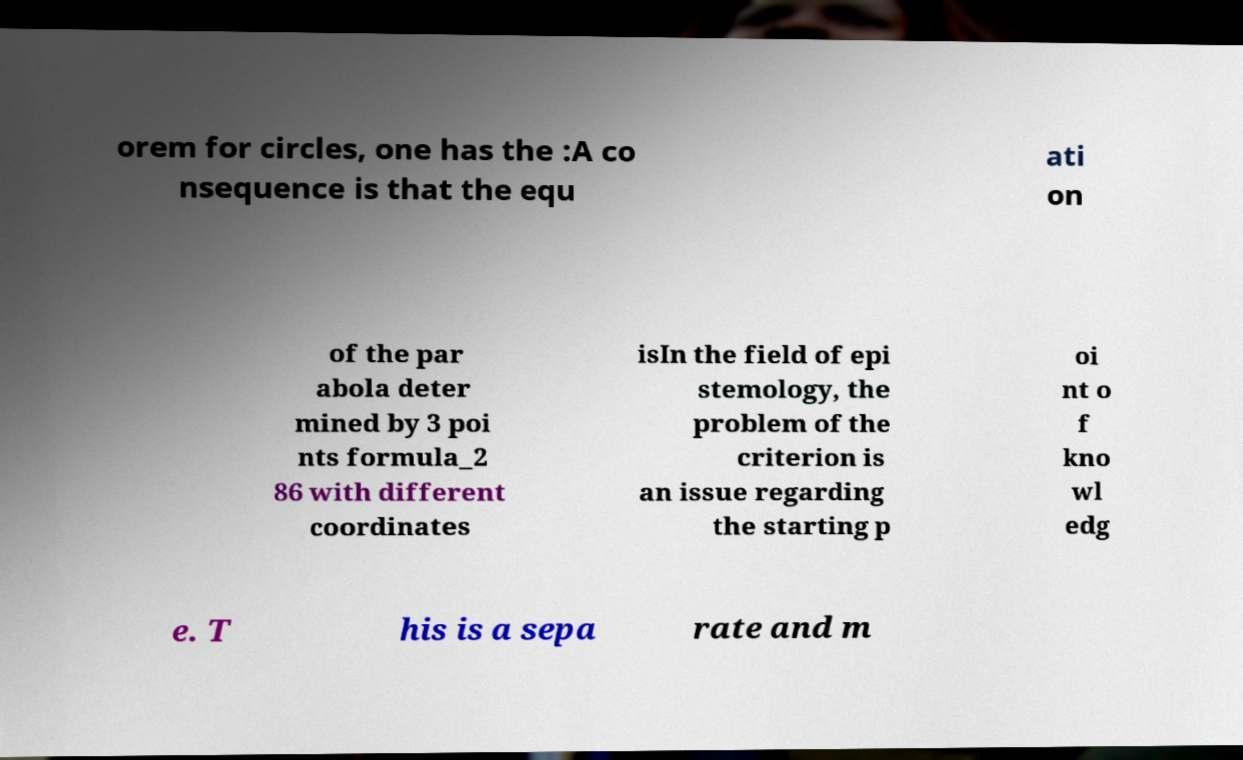Could you extract and type out the text from this image? orem for circles, one has the :A co nsequence is that the equ ati on of the par abola deter mined by 3 poi nts formula_2 86 with different coordinates isIn the field of epi stemology, the problem of the criterion is an issue regarding the starting p oi nt o f kno wl edg e. T his is a sepa rate and m 